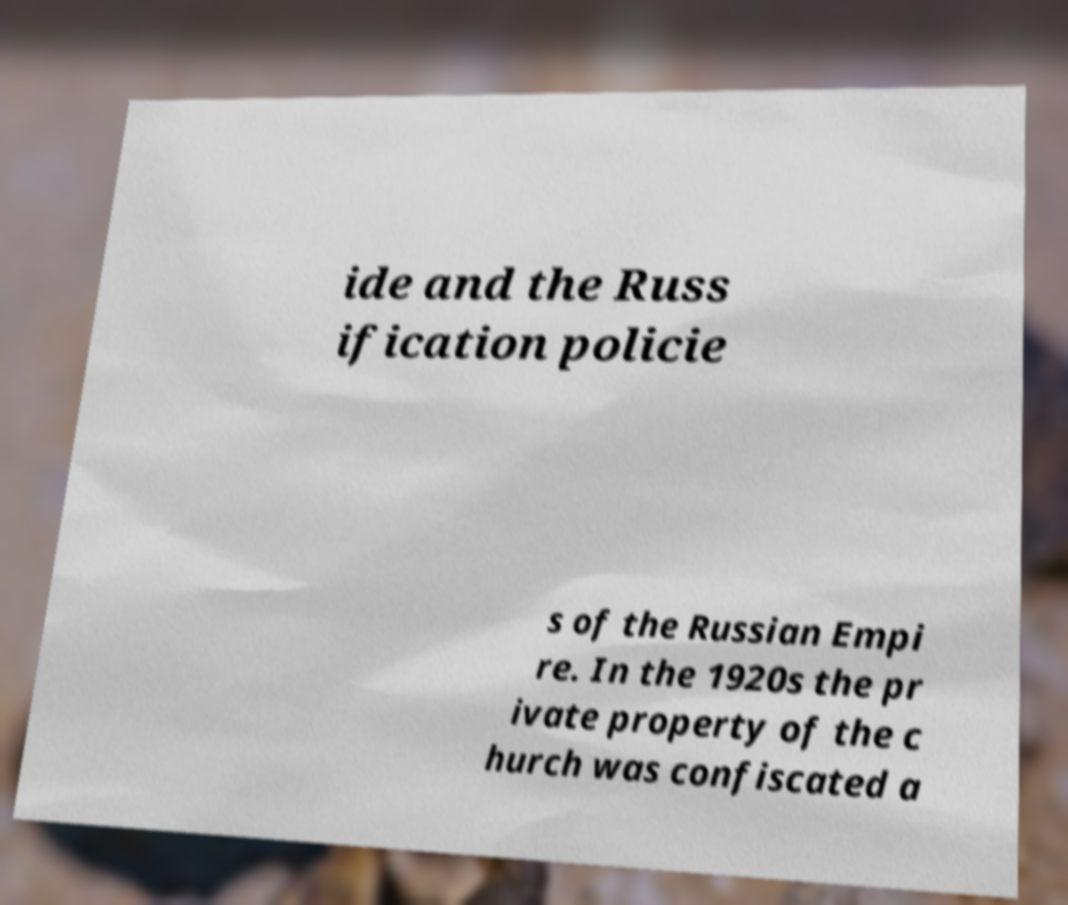There's text embedded in this image that I need extracted. Can you transcribe it verbatim? ide and the Russ ification policie s of the Russian Empi re. In the 1920s the pr ivate property of the c hurch was confiscated a 